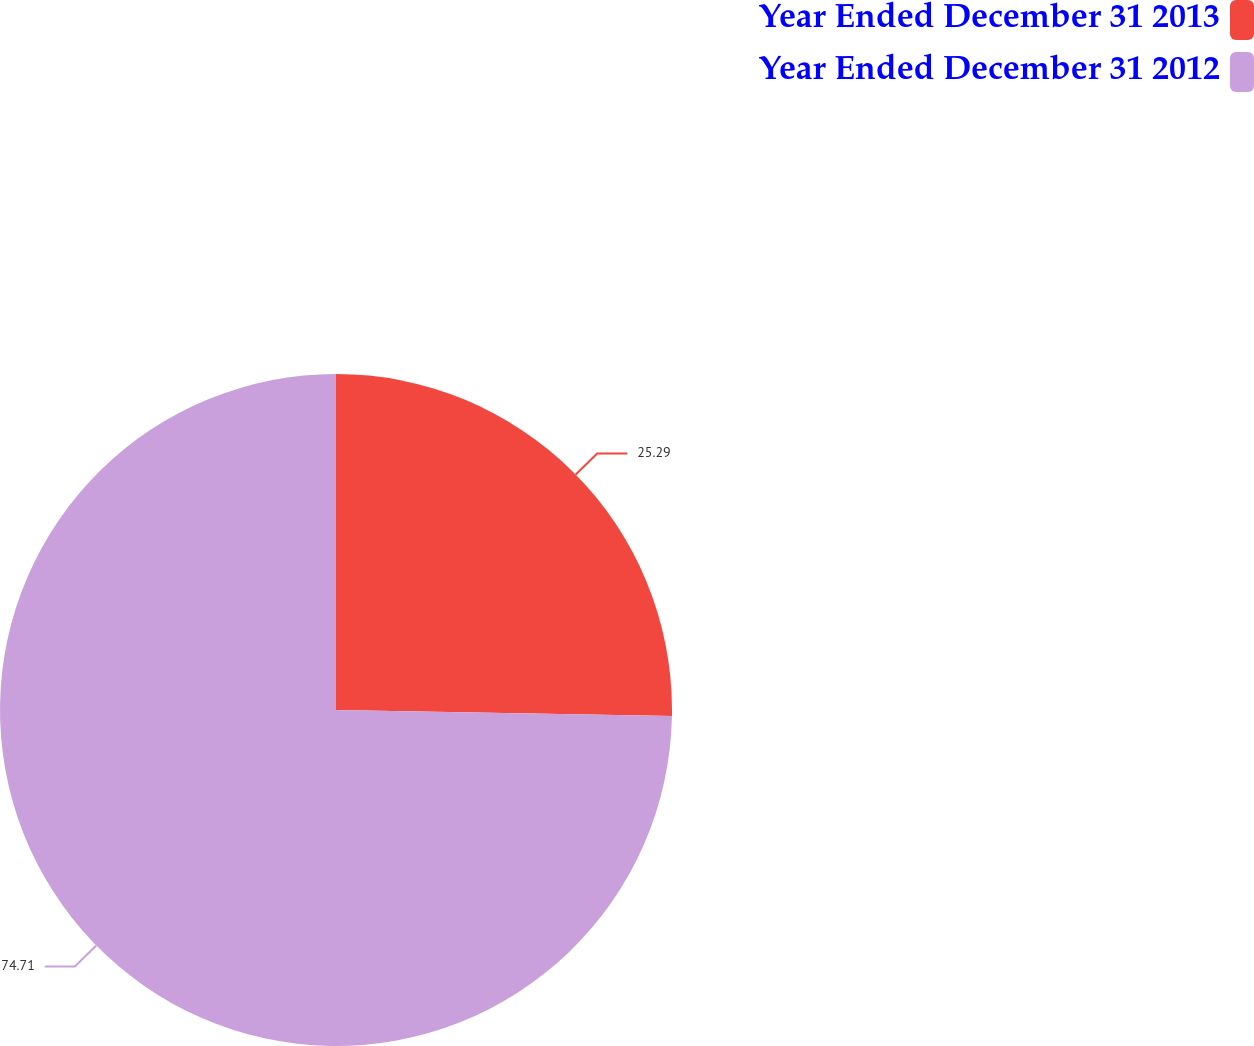Convert chart to OTSL. <chart><loc_0><loc_0><loc_500><loc_500><pie_chart><fcel>Year Ended December 31 2013<fcel>Year Ended December 31 2012<nl><fcel>25.29%<fcel>74.71%<nl></chart> 